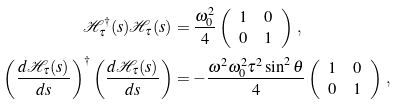<formula> <loc_0><loc_0><loc_500><loc_500>\mathcal { H } _ { \tau } ^ { \dagger } ( s ) \mathcal { H } _ { \tau } ( s ) & = \frac { \omega _ { 0 } ^ { 2 } } { 4 } \left ( \begin{array} { l r } 1 & 0 \\ 0 & 1 \end{array} \right ) \, , \\ \left ( \frac { d \mathcal { H } _ { \tau } ( s ) } { d s } \right ) ^ { \dagger } \left ( \frac { d \mathcal { H } _ { \tau } ( s ) } { d s } \right ) & = - \frac { \omega ^ { 2 } \omega _ { 0 } ^ { 2 } \tau ^ { 2 } \sin ^ { 2 } \theta } { 4 } \left ( \begin{array} { l r } 1 & 0 \\ 0 & 1 \end{array} \right ) \, ,</formula> 